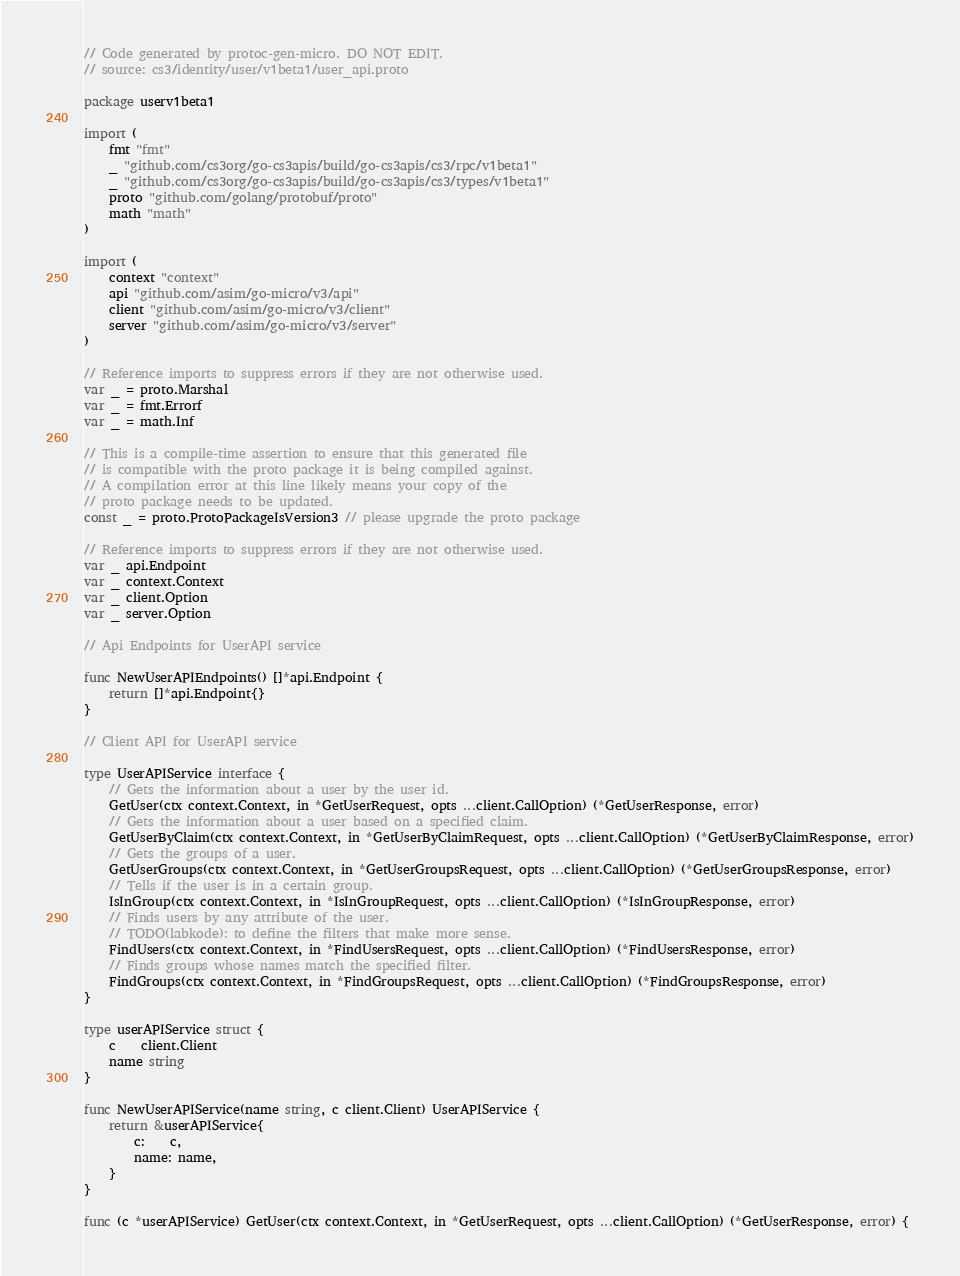<code> <loc_0><loc_0><loc_500><loc_500><_Go_>// Code generated by protoc-gen-micro. DO NOT EDIT.
// source: cs3/identity/user/v1beta1/user_api.proto

package userv1beta1

import (
	fmt "fmt"
	_ "github.com/cs3org/go-cs3apis/build/go-cs3apis/cs3/rpc/v1beta1"
	_ "github.com/cs3org/go-cs3apis/build/go-cs3apis/cs3/types/v1beta1"
	proto "github.com/golang/protobuf/proto"
	math "math"
)

import (
	context "context"
	api "github.com/asim/go-micro/v3/api"
	client "github.com/asim/go-micro/v3/client"
	server "github.com/asim/go-micro/v3/server"
)

// Reference imports to suppress errors if they are not otherwise used.
var _ = proto.Marshal
var _ = fmt.Errorf
var _ = math.Inf

// This is a compile-time assertion to ensure that this generated file
// is compatible with the proto package it is being compiled against.
// A compilation error at this line likely means your copy of the
// proto package needs to be updated.
const _ = proto.ProtoPackageIsVersion3 // please upgrade the proto package

// Reference imports to suppress errors if they are not otherwise used.
var _ api.Endpoint
var _ context.Context
var _ client.Option
var _ server.Option

// Api Endpoints for UserAPI service

func NewUserAPIEndpoints() []*api.Endpoint {
	return []*api.Endpoint{}
}

// Client API for UserAPI service

type UserAPIService interface {
	// Gets the information about a user by the user id.
	GetUser(ctx context.Context, in *GetUserRequest, opts ...client.CallOption) (*GetUserResponse, error)
	// Gets the information about a user based on a specified claim.
	GetUserByClaim(ctx context.Context, in *GetUserByClaimRequest, opts ...client.CallOption) (*GetUserByClaimResponse, error)
	// Gets the groups of a user.
	GetUserGroups(ctx context.Context, in *GetUserGroupsRequest, opts ...client.CallOption) (*GetUserGroupsResponse, error)
	// Tells if the user is in a certain group.
	IsInGroup(ctx context.Context, in *IsInGroupRequest, opts ...client.CallOption) (*IsInGroupResponse, error)
	// Finds users by any attribute of the user.
	// TODO(labkode): to define the filters that make more sense.
	FindUsers(ctx context.Context, in *FindUsersRequest, opts ...client.CallOption) (*FindUsersResponse, error)
	// Finds groups whose names match the specified filter.
	FindGroups(ctx context.Context, in *FindGroupsRequest, opts ...client.CallOption) (*FindGroupsResponse, error)
}

type userAPIService struct {
	c    client.Client
	name string
}

func NewUserAPIService(name string, c client.Client) UserAPIService {
	return &userAPIService{
		c:    c,
		name: name,
	}
}

func (c *userAPIService) GetUser(ctx context.Context, in *GetUserRequest, opts ...client.CallOption) (*GetUserResponse, error) {</code> 